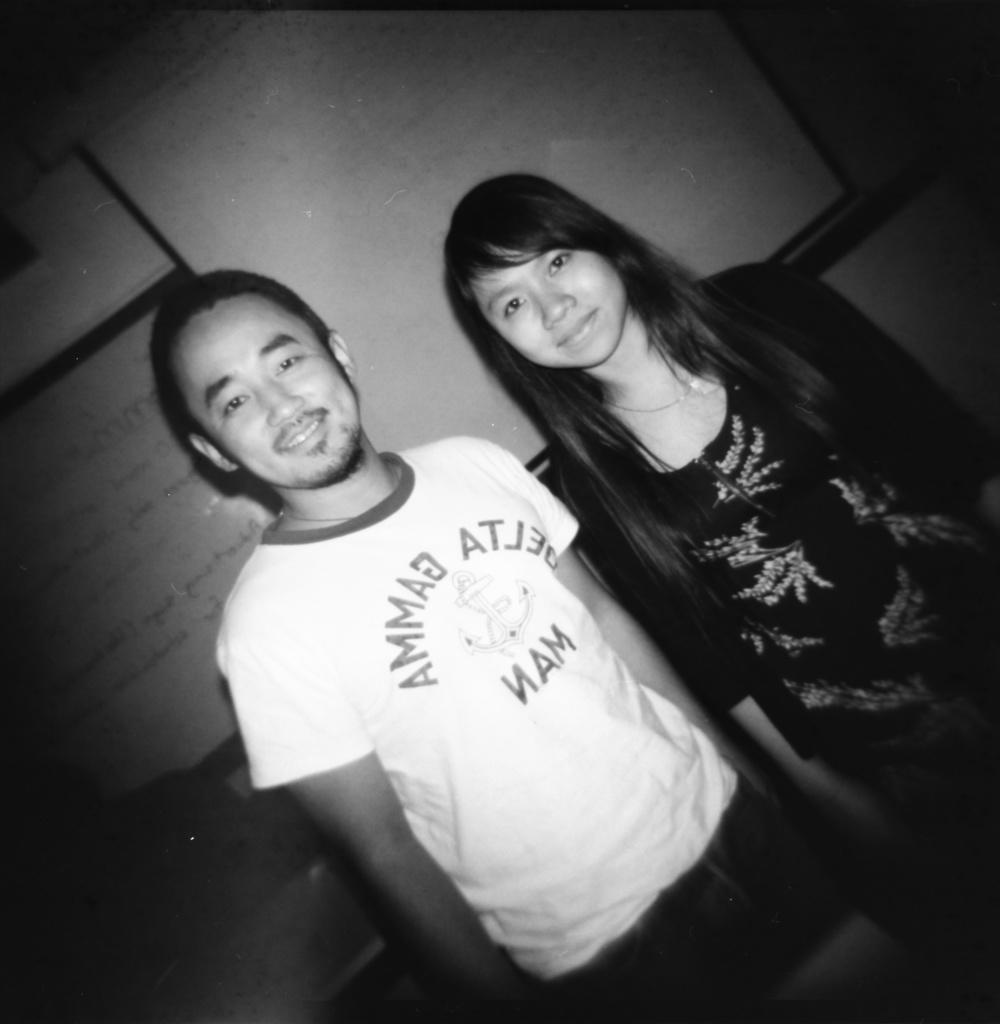What is: What is the color scheme of the image? The image is black and white. Who can be seen in the image? There is a man and a woman in the image. What are the man and woman doing in the image? The man and woman are standing and smiling. What can be seen in the background of the image? There are boards visible in the background of the image. What type of trouble is the man playing on his toes in the image? There is no indication of trouble or the man playing a guitar on his toes in the image. 